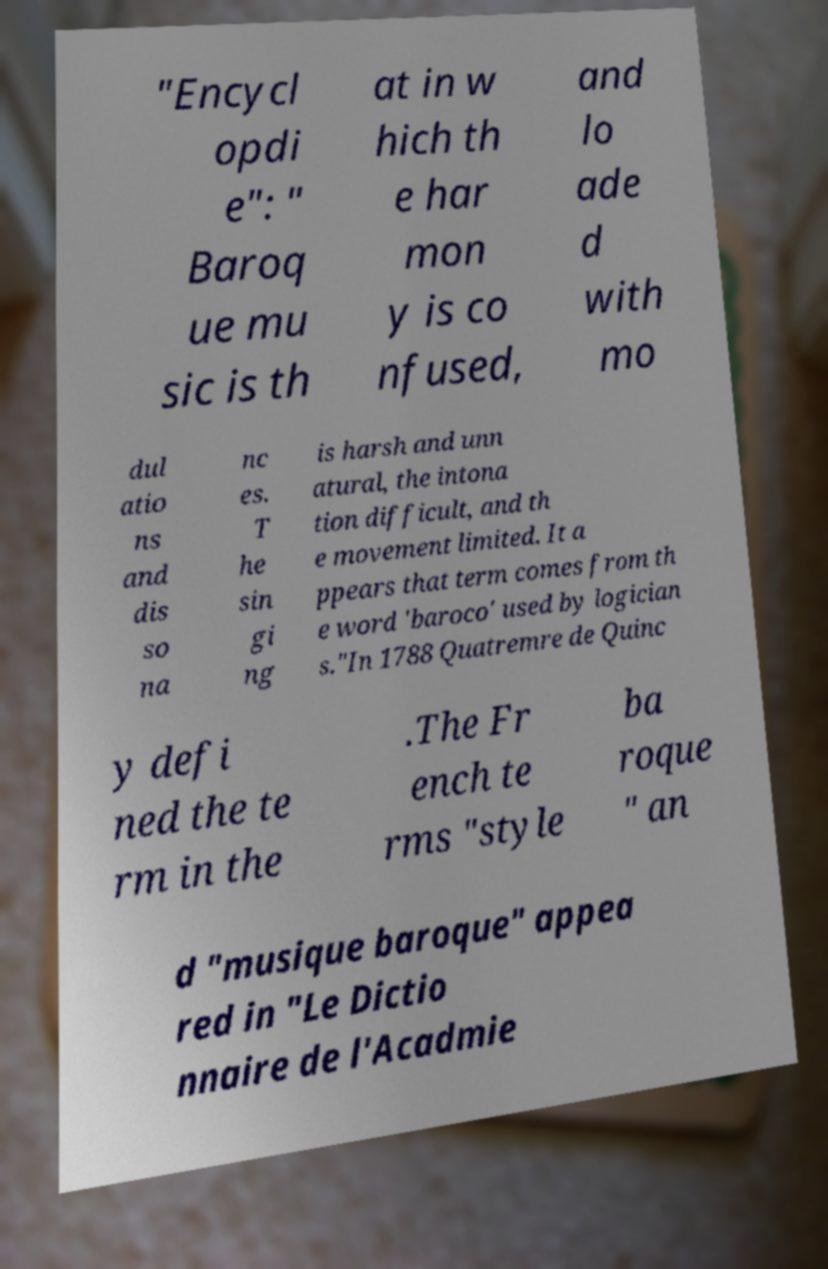I need the written content from this picture converted into text. Can you do that? "Encycl opdi e": " Baroq ue mu sic is th at in w hich th e har mon y is co nfused, and lo ade d with mo dul atio ns and dis so na nc es. T he sin gi ng is harsh and unn atural, the intona tion difficult, and th e movement limited. It a ppears that term comes from th e word 'baroco' used by logician s."In 1788 Quatremre de Quinc y defi ned the te rm in the .The Fr ench te rms "style ba roque " an d "musique baroque" appea red in "Le Dictio nnaire de l'Acadmie 